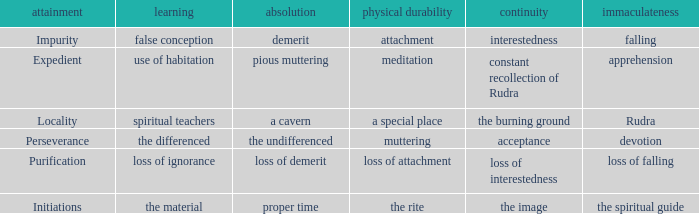 what's the permanence of the body where constancy is interestedness Attachment. 